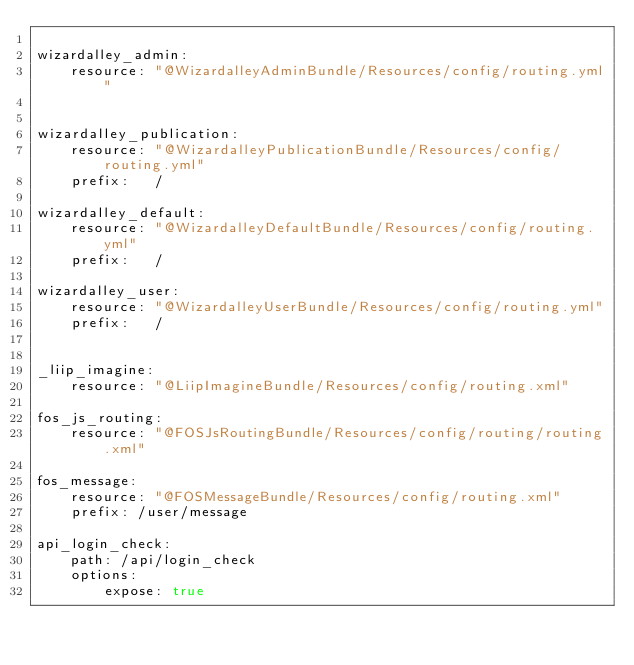Convert code to text. <code><loc_0><loc_0><loc_500><loc_500><_YAML_>
wizardalley_admin:
    resource: "@WizardalleyAdminBundle/Resources/config/routing.yml"


wizardalley_publication:
    resource: "@WizardalleyPublicationBundle/Resources/config/routing.yml"
    prefix:   /

wizardalley_default:
    resource: "@WizardalleyDefaultBundle/Resources/config/routing.yml"
    prefix:   /

wizardalley_user:
    resource: "@WizardalleyUserBundle/Resources/config/routing.yml"
    prefix:   /


_liip_imagine:
    resource: "@LiipImagineBundle/Resources/config/routing.xml"

fos_js_routing:
    resource: "@FOSJsRoutingBundle/Resources/config/routing/routing.xml"

fos_message:
    resource: "@FOSMessageBundle/Resources/config/routing.xml"
    prefix: /user/message

api_login_check:
    path: /api/login_check
    options:
        expose: true</code> 